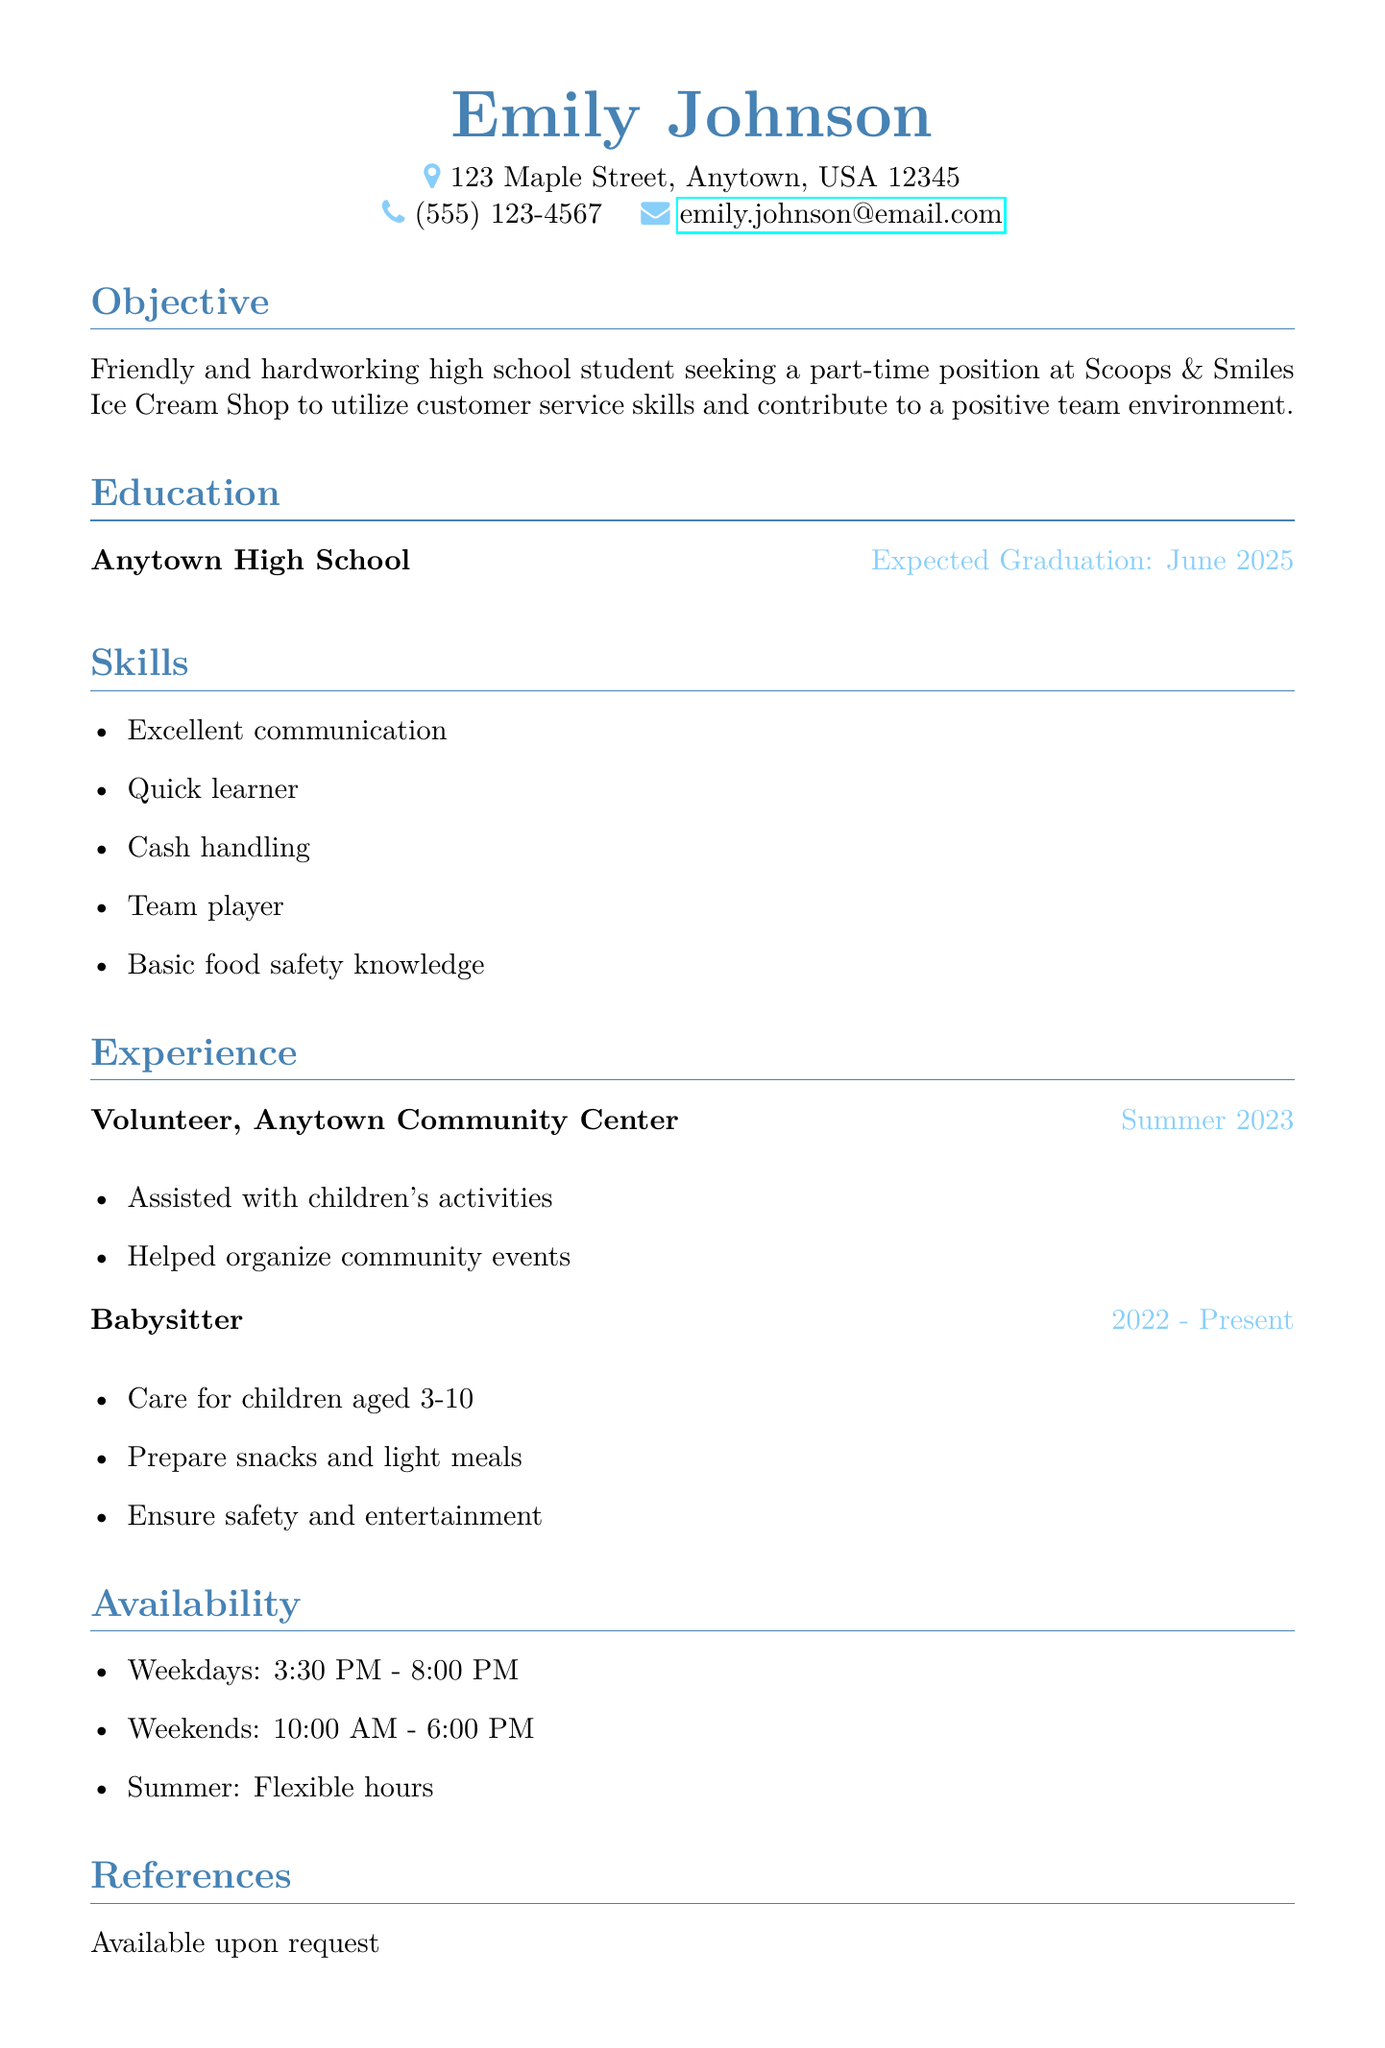What is the name of the applicant? The name of the applicant is listed at the top of the document.
Answer: Emily Johnson What is the objective of Emily Johnson? The objective states her goal for seeking the part-time position and her skills.
Answer: Friendly and hardworking high school student seeking a part-time position at Scoops & Smiles Ice Cream Shop to utilize customer service skills and contribute to a positive team environment When is Emily expected to graduate? The expected graduation is mentioned in the education section.
Answer: June 2025 What skills does Emily have? The skills are listed in a bullet-point format under the skills section.
Answer: Excellent communication, Quick learner, Cash handling, Team player, Basic food safety knowledge What was Emily's role at the Anytown Community Center? The role is identified in the experience section, specifying her volunteer position.
Answer: Volunteer What is Emily's availability on weekends? The availability for weekends is specified clearly in the document.
Answer: 10:00 AM - 6:00 PM How long has Emily been babysitting? The duration Emily has been babysitting is indicated in the experience section.
Answer: 2022 - Present What kind of environment does Emily aim to contribute to? This is expressed in her objective statement, which describes her aim for the work environment.
Answer: Positive team environment Is Emily's reference information available? The references section states whether the information is accessible.
Answer: Available upon request 